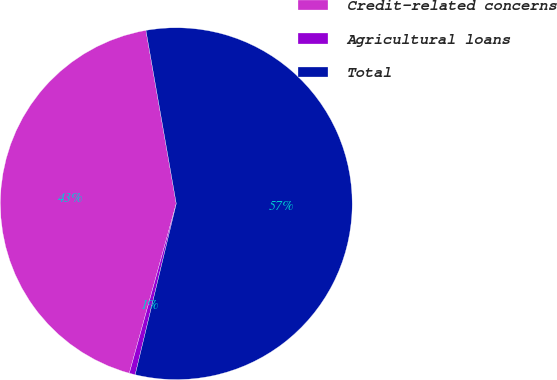<chart> <loc_0><loc_0><loc_500><loc_500><pie_chart><fcel>Credit-related concerns<fcel>Agricultural loans<fcel>Total<nl><fcel>42.94%<fcel>0.55%<fcel>56.51%<nl></chart> 